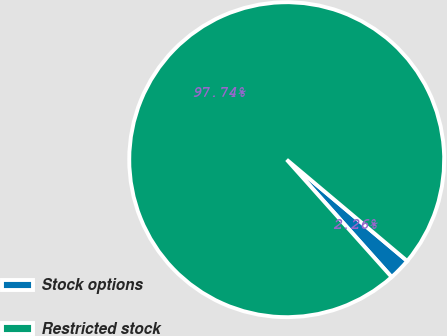<chart> <loc_0><loc_0><loc_500><loc_500><pie_chart><fcel>Stock options<fcel>Restricted stock<nl><fcel>2.26%<fcel>97.74%<nl></chart> 